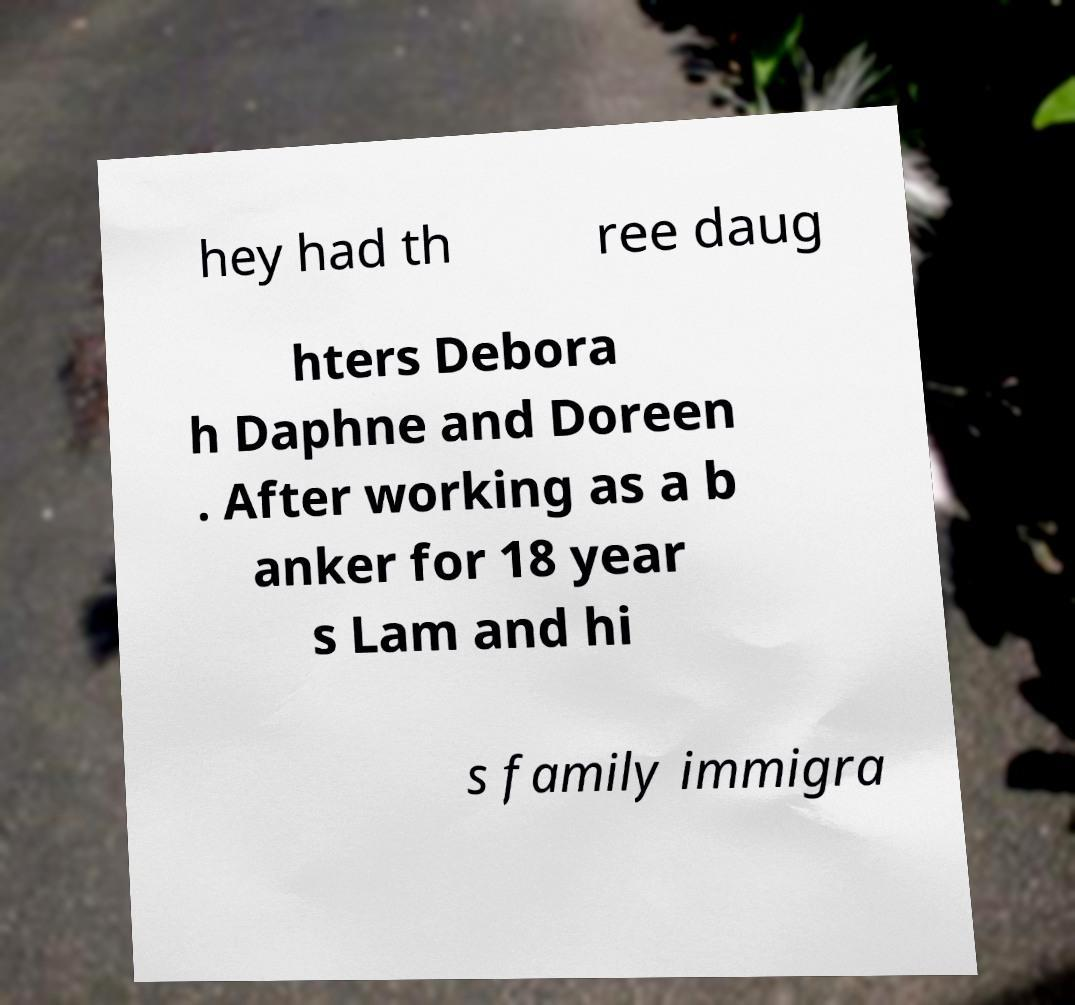Please read and relay the text visible in this image. What does it say? hey had th ree daug hters Debora h Daphne and Doreen . After working as a b anker for 18 year s Lam and hi s family immigra 